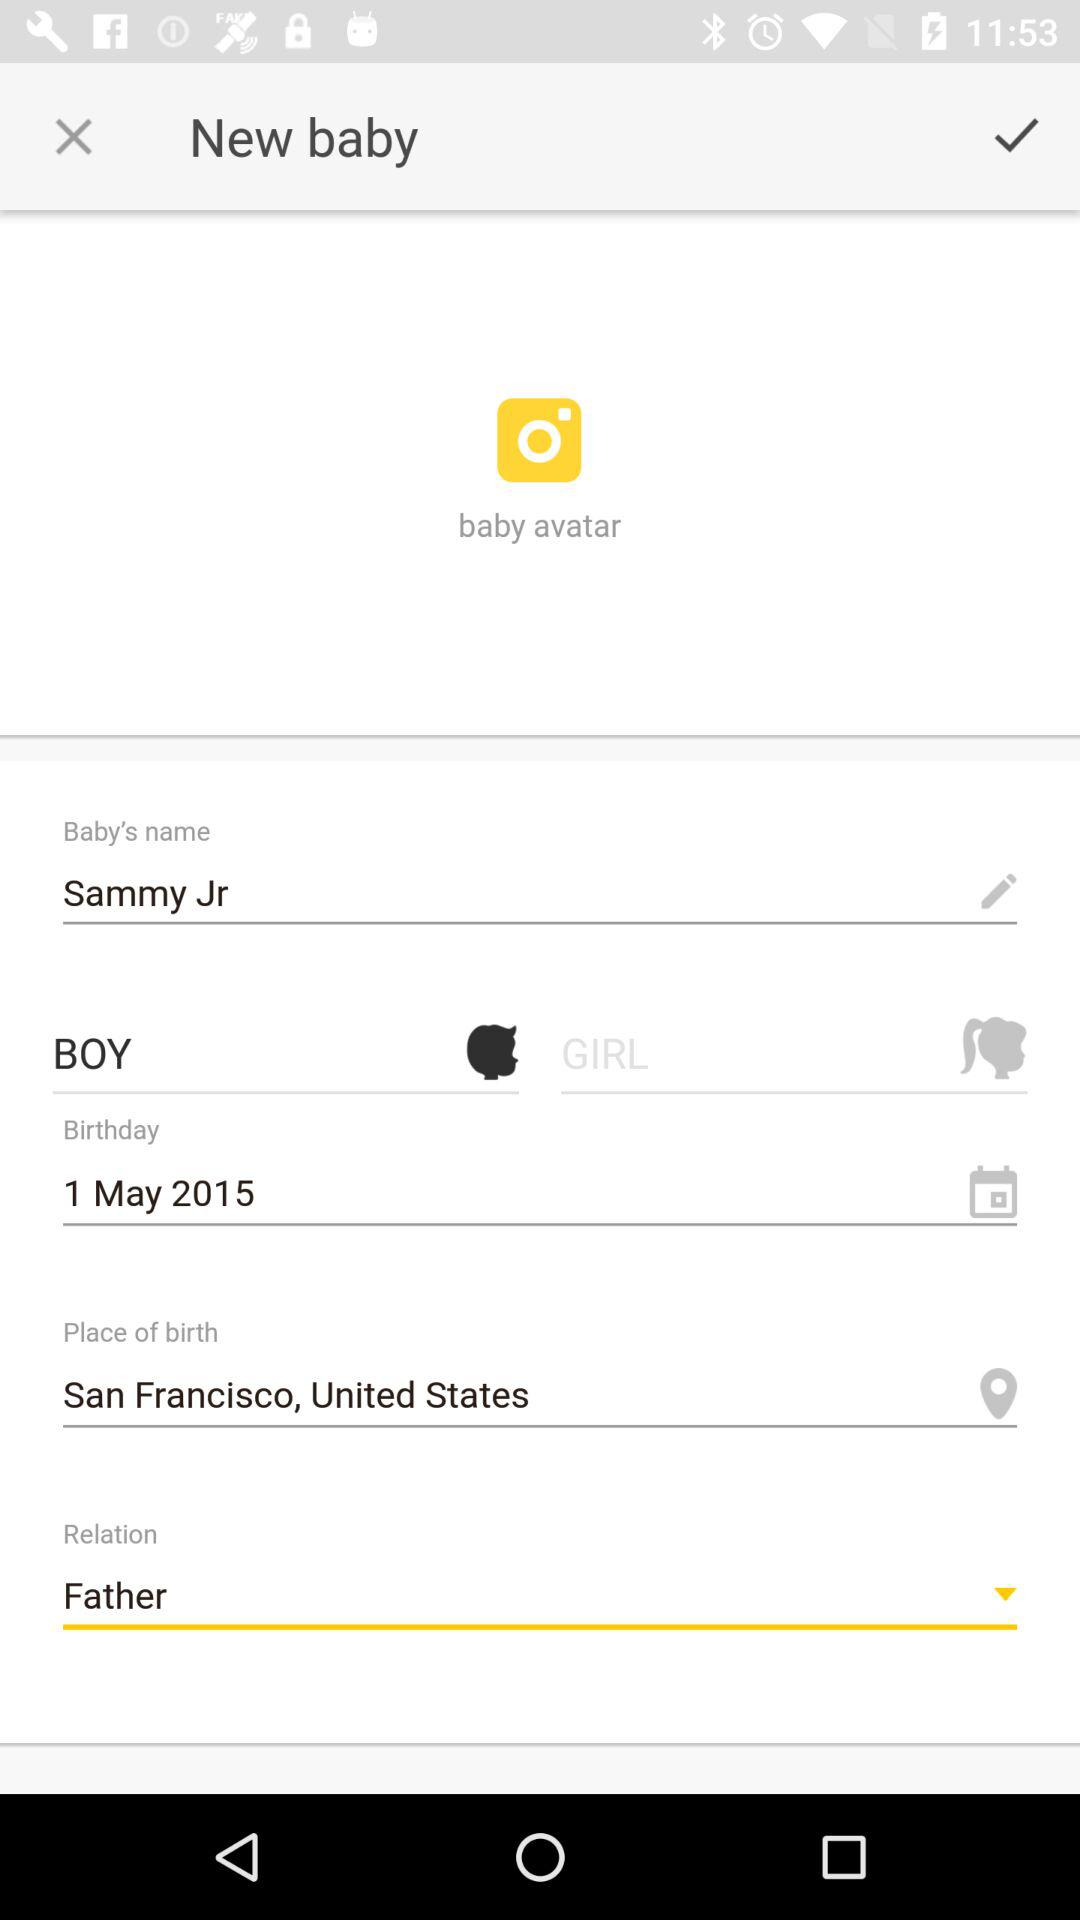What is the baby's name? The name of the baby is Sammy Jr. 